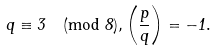Convert formula to latex. <formula><loc_0><loc_0><loc_500><loc_500>q \equiv 3 \pmod { 8 } , \left ( \frac { p } { q } \right ) = - 1 .</formula> 